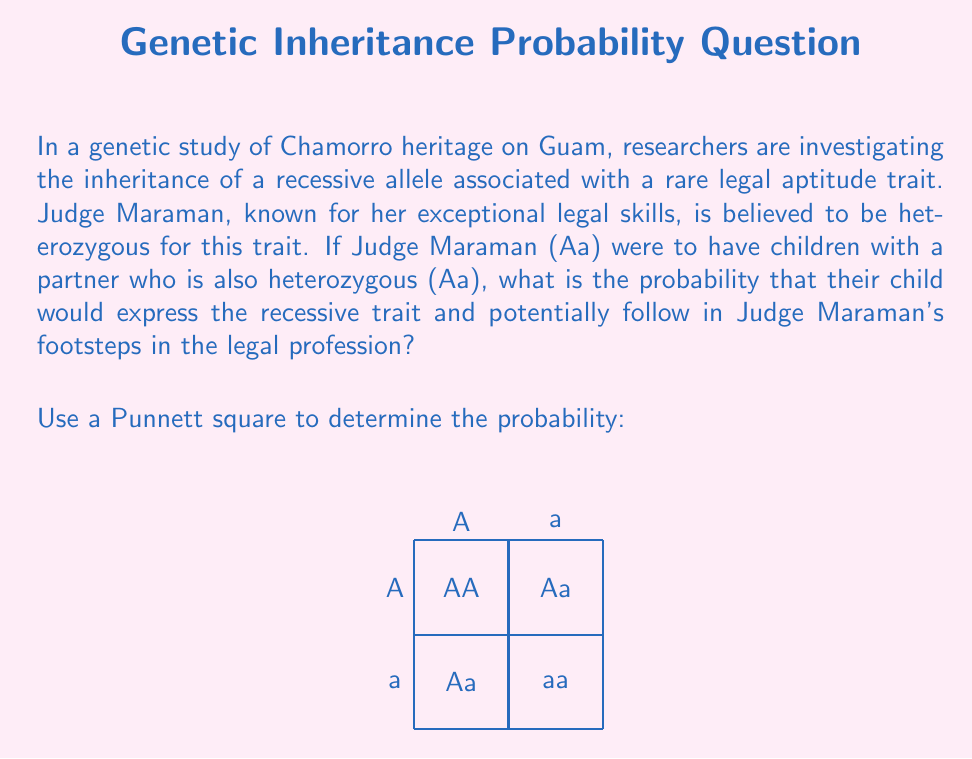What is the answer to this math problem? To solve this problem, we'll use a Punnett square and apply probability concepts:

1) First, let's set up the Punnett square:
   - Judge Maraman's genotype: Aa
   - Partner's genotype: Aa

2) The Punnett square shows the possible genotype combinations:
   AA, Aa, Aa, aa

3) To express the recessive trait, a child must inherit the 'a' allele from both parents, resulting in the 'aa' genotype.

4) From the Punnett square, we can see that there is 1 out of 4 possible outcomes where the child has the 'aa' genotype.

5) The probability of an event is calculated by dividing the number of favorable outcomes by the total number of possible outcomes:

   $$P(\text{aa genotype}) = \frac{\text{Number of aa outcomes}}{\text{Total number of outcomes}} = \frac{1}{4} = 0.25$$

6) To express this as a percentage:
   $$0.25 \times 100\% = 25\%$$

Therefore, the probability that Judge Maraman and her partner would have a child expressing the recessive legal aptitude trait is 25% or 1/4.
Answer: 25% or $\frac{1}{4}$ 